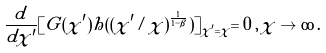<formula> <loc_0><loc_0><loc_500><loc_500>\frac { d } { d \chi ^ { \prime } } [ G ( \chi ^ { \prime } ) h ( ( \chi ^ { \prime } / \chi ) ^ { \frac { 1 } { 1 - \beta } } ) ] _ { \chi ^ { \prime } = \chi } = 0 \, , \, \chi \to \infty \, .</formula> 